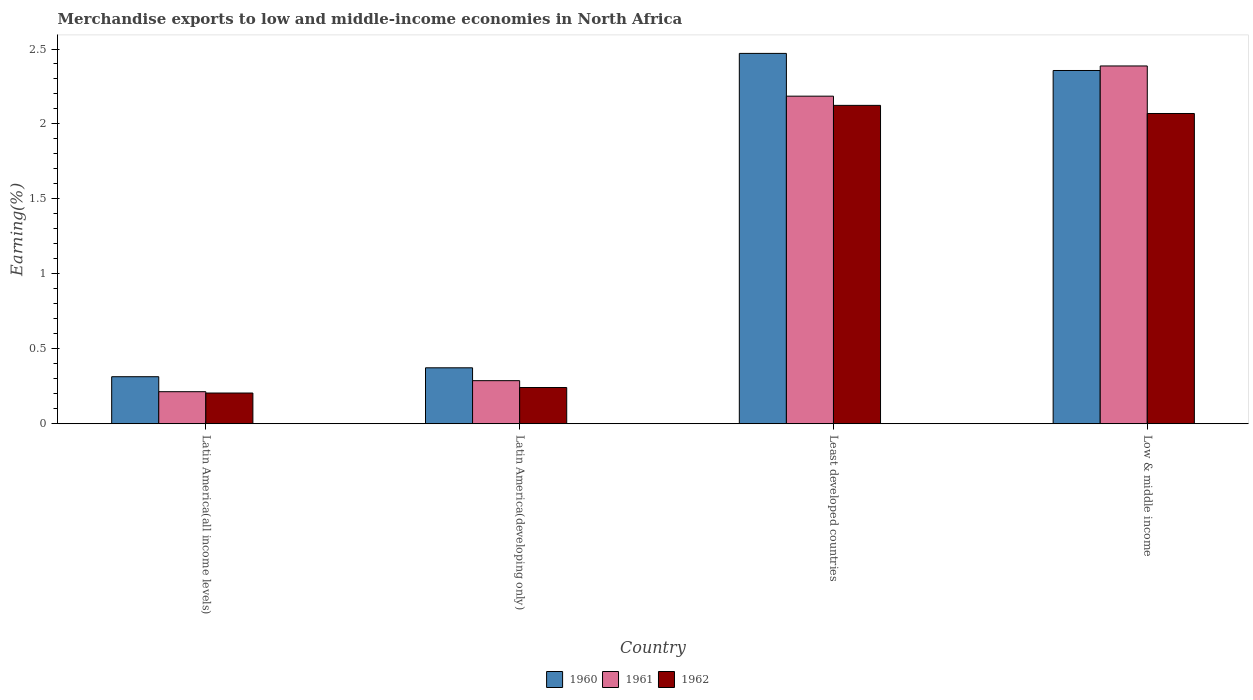How many different coloured bars are there?
Offer a very short reply. 3. How many groups of bars are there?
Offer a very short reply. 4. Are the number of bars on each tick of the X-axis equal?
Offer a very short reply. Yes. How many bars are there on the 4th tick from the left?
Give a very brief answer. 3. How many bars are there on the 2nd tick from the right?
Your response must be concise. 3. What is the label of the 1st group of bars from the left?
Your response must be concise. Latin America(all income levels). In how many cases, is the number of bars for a given country not equal to the number of legend labels?
Your answer should be compact. 0. What is the percentage of amount earned from merchandise exports in 1961 in Latin America(developing only)?
Offer a terse response. 0.29. Across all countries, what is the maximum percentage of amount earned from merchandise exports in 1961?
Provide a short and direct response. 2.39. Across all countries, what is the minimum percentage of amount earned from merchandise exports in 1961?
Give a very brief answer. 0.21. In which country was the percentage of amount earned from merchandise exports in 1961 maximum?
Offer a terse response. Low & middle income. In which country was the percentage of amount earned from merchandise exports in 1960 minimum?
Your answer should be compact. Latin America(all income levels). What is the total percentage of amount earned from merchandise exports in 1962 in the graph?
Provide a short and direct response. 4.64. What is the difference between the percentage of amount earned from merchandise exports in 1960 in Latin America(all income levels) and that in Latin America(developing only)?
Offer a very short reply. -0.06. What is the difference between the percentage of amount earned from merchandise exports in 1960 in Low & middle income and the percentage of amount earned from merchandise exports in 1962 in Least developed countries?
Make the answer very short. 0.23. What is the average percentage of amount earned from merchandise exports in 1960 per country?
Keep it short and to the point. 1.38. What is the difference between the percentage of amount earned from merchandise exports of/in 1961 and percentage of amount earned from merchandise exports of/in 1960 in Least developed countries?
Ensure brevity in your answer.  -0.29. In how many countries, is the percentage of amount earned from merchandise exports in 1962 greater than 1.5 %?
Your answer should be very brief. 2. What is the ratio of the percentage of amount earned from merchandise exports in 1962 in Latin America(all income levels) to that in Least developed countries?
Your answer should be very brief. 0.1. Is the difference between the percentage of amount earned from merchandise exports in 1961 in Latin America(all income levels) and Least developed countries greater than the difference between the percentage of amount earned from merchandise exports in 1960 in Latin America(all income levels) and Least developed countries?
Your response must be concise. Yes. What is the difference between the highest and the second highest percentage of amount earned from merchandise exports in 1961?
Your answer should be very brief. -2.1. What is the difference between the highest and the lowest percentage of amount earned from merchandise exports in 1960?
Make the answer very short. 2.16. In how many countries, is the percentage of amount earned from merchandise exports in 1962 greater than the average percentage of amount earned from merchandise exports in 1962 taken over all countries?
Offer a terse response. 2. What does the 2nd bar from the left in Latin America(developing only) represents?
Your answer should be very brief. 1961. What does the 3rd bar from the right in Latin America(developing only) represents?
Your response must be concise. 1960. Is it the case that in every country, the sum of the percentage of amount earned from merchandise exports in 1962 and percentage of amount earned from merchandise exports in 1961 is greater than the percentage of amount earned from merchandise exports in 1960?
Make the answer very short. Yes. How many countries are there in the graph?
Keep it short and to the point. 4. Are the values on the major ticks of Y-axis written in scientific E-notation?
Your answer should be compact. No. Does the graph contain any zero values?
Make the answer very short. No. Does the graph contain grids?
Your response must be concise. No. How many legend labels are there?
Ensure brevity in your answer.  3. How are the legend labels stacked?
Ensure brevity in your answer.  Horizontal. What is the title of the graph?
Your answer should be very brief. Merchandise exports to low and middle-income economies in North Africa. What is the label or title of the Y-axis?
Make the answer very short. Earning(%). What is the Earning(%) of 1960 in Latin America(all income levels)?
Provide a succinct answer. 0.31. What is the Earning(%) in 1961 in Latin America(all income levels)?
Your answer should be compact. 0.21. What is the Earning(%) in 1962 in Latin America(all income levels)?
Give a very brief answer. 0.2. What is the Earning(%) in 1960 in Latin America(developing only)?
Make the answer very short. 0.37. What is the Earning(%) in 1961 in Latin America(developing only)?
Give a very brief answer. 0.29. What is the Earning(%) of 1962 in Latin America(developing only)?
Provide a short and direct response. 0.24. What is the Earning(%) of 1960 in Least developed countries?
Ensure brevity in your answer.  2.47. What is the Earning(%) in 1961 in Least developed countries?
Keep it short and to the point. 2.19. What is the Earning(%) in 1962 in Least developed countries?
Keep it short and to the point. 2.12. What is the Earning(%) in 1960 in Low & middle income?
Offer a very short reply. 2.36. What is the Earning(%) in 1961 in Low & middle income?
Offer a terse response. 2.39. What is the Earning(%) in 1962 in Low & middle income?
Your answer should be very brief. 2.07. Across all countries, what is the maximum Earning(%) in 1960?
Your response must be concise. 2.47. Across all countries, what is the maximum Earning(%) in 1961?
Provide a succinct answer. 2.39. Across all countries, what is the maximum Earning(%) of 1962?
Keep it short and to the point. 2.12. Across all countries, what is the minimum Earning(%) of 1960?
Your answer should be very brief. 0.31. Across all countries, what is the minimum Earning(%) of 1961?
Provide a short and direct response. 0.21. Across all countries, what is the minimum Earning(%) in 1962?
Keep it short and to the point. 0.2. What is the total Earning(%) of 1960 in the graph?
Your response must be concise. 5.51. What is the total Earning(%) in 1961 in the graph?
Offer a very short reply. 5.07. What is the total Earning(%) in 1962 in the graph?
Offer a terse response. 4.64. What is the difference between the Earning(%) in 1960 in Latin America(all income levels) and that in Latin America(developing only)?
Your response must be concise. -0.06. What is the difference between the Earning(%) in 1961 in Latin America(all income levels) and that in Latin America(developing only)?
Offer a very short reply. -0.07. What is the difference between the Earning(%) of 1962 in Latin America(all income levels) and that in Latin America(developing only)?
Offer a terse response. -0.04. What is the difference between the Earning(%) in 1960 in Latin America(all income levels) and that in Least developed countries?
Keep it short and to the point. -2.16. What is the difference between the Earning(%) in 1961 in Latin America(all income levels) and that in Least developed countries?
Make the answer very short. -1.97. What is the difference between the Earning(%) in 1962 in Latin America(all income levels) and that in Least developed countries?
Ensure brevity in your answer.  -1.92. What is the difference between the Earning(%) in 1960 in Latin America(all income levels) and that in Low & middle income?
Keep it short and to the point. -2.04. What is the difference between the Earning(%) of 1961 in Latin America(all income levels) and that in Low & middle income?
Your response must be concise. -2.17. What is the difference between the Earning(%) in 1962 in Latin America(all income levels) and that in Low & middle income?
Your response must be concise. -1.86. What is the difference between the Earning(%) of 1960 in Latin America(developing only) and that in Least developed countries?
Keep it short and to the point. -2.1. What is the difference between the Earning(%) in 1961 in Latin America(developing only) and that in Least developed countries?
Provide a short and direct response. -1.9. What is the difference between the Earning(%) in 1962 in Latin America(developing only) and that in Least developed countries?
Provide a short and direct response. -1.88. What is the difference between the Earning(%) in 1960 in Latin America(developing only) and that in Low & middle income?
Ensure brevity in your answer.  -1.98. What is the difference between the Earning(%) in 1961 in Latin America(developing only) and that in Low & middle income?
Your answer should be compact. -2.1. What is the difference between the Earning(%) in 1962 in Latin America(developing only) and that in Low & middle income?
Keep it short and to the point. -1.83. What is the difference between the Earning(%) in 1960 in Least developed countries and that in Low & middle income?
Your answer should be very brief. 0.11. What is the difference between the Earning(%) in 1961 in Least developed countries and that in Low & middle income?
Offer a terse response. -0.2. What is the difference between the Earning(%) in 1962 in Least developed countries and that in Low & middle income?
Offer a terse response. 0.05. What is the difference between the Earning(%) of 1960 in Latin America(all income levels) and the Earning(%) of 1961 in Latin America(developing only)?
Provide a short and direct response. 0.03. What is the difference between the Earning(%) in 1960 in Latin America(all income levels) and the Earning(%) in 1962 in Latin America(developing only)?
Provide a succinct answer. 0.07. What is the difference between the Earning(%) of 1961 in Latin America(all income levels) and the Earning(%) of 1962 in Latin America(developing only)?
Give a very brief answer. -0.03. What is the difference between the Earning(%) in 1960 in Latin America(all income levels) and the Earning(%) in 1961 in Least developed countries?
Keep it short and to the point. -1.87. What is the difference between the Earning(%) in 1960 in Latin America(all income levels) and the Earning(%) in 1962 in Least developed countries?
Your answer should be compact. -1.81. What is the difference between the Earning(%) in 1961 in Latin America(all income levels) and the Earning(%) in 1962 in Least developed countries?
Your answer should be very brief. -1.91. What is the difference between the Earning(%) in 1960 in Latin America(all income levels) and the Earning(%) in 1961 in Low & middle income?
Offer a terse response. -2.07. What is the difference between the Earning(%) of 1960 in Latin America(all income levels) and the Earning(%) of 1962 in Low & middle income?
Provide a succinct answer. -1.76. What is the difference between the Earning(%) in 1961 in Latin America(all income levels) and the Earning(%) in 1962 in Low & middle income?
Your response must be concise. -1.86. What is the difference between the Earning(%) in 1960 in Latin America(developing only) and the Earning(%) in 1961 in Least developed countries?
Make the answer very short. -1.81. What is the difference between the Earning(%) of 1960 in Latin America(developing only) and the Earning(%) of 1962 in Least developed countries?
Offer a very short reply. -1.75. What is the difference between the Earning(%) of 1961 in Latin America(developing only) and the Earning(%) of 1962 in Least developed countries?
Provide a succinct answer. -1.84. What is the difference between the Earning(%) of 1960 in Latin America(developing only) and the Earning(%) of 1961 in Low & middle income?
Offer a terse response. -2.01. What is the difference between the Earning(%) in 1960 in Latin America(developing only) and the Earning(%) in 1962 in Low & middle income?
Keep it short and to the point. -1.7. What is the difference between the Earning(%) of 1961 in Latin America(developing only) and the Earning(%) of 1962 in Low & middle income?
Offer a terse response. -1.78. What is the difference between the Earning(%) of 1960 in Least developed countries and the Earning(%) of 1961 in Low & middle income?
Offer a very short reply. 0.08. What is the difference between the Earning(%) of 1960 in Least developed countries and the Earning(%) of 1962 in Low & middle income?
Ensure brevity in your answer.  0.4. What is the difference between the Earning(%) in 1961 in Least developed countries and the Earning(%) in 1962 in Low & middle income?
Offer a terse response. 0.12. What is the average Earning(%) of 1960 per country?
Provide a succinct answer. 1.38. What is the average Earning(%) in 1961 per country?
Your answer should be very brief. 1.27. What is the average Earning(%) of 1962 per country?
Your answer should be very brief. 1.16. What is the difference between the Earning(%) of 1960 and Earning(%) of 1961 in Latin America(all income levels)?
Give a very brief answer. 0.1. What is the difference between the Earning(%) in 1960 and Earning(%) in 1962 in Latin America(all income levels)?
Make the answer very short. 0.11. What is the difference between the Earning(%) of 1961 and Earning(%) of 1962 in Latin America(all income levels)?
Ensure brevity in your answer.  0.01. What is the difference between the Earning(%) of 1960 and Earning(%) of 1961 in Latin America(developing only)?
Ensure brevity in your answer.  0.09. What is the difference between the Earning(%) of 1960 and Earning(%) of 1962 in Latin America(developing only)?
Provide a succinct answer. 0.13. What is the difference between the Earning(%) of 1961 and Earning(%) of 1962 in Latin America(developing only)?
Offer a very short reply. 0.05. What is the difference between the Earning(%) in 1960 and Earning(%) in 1961 in Least developed countries?
Provide a short and direct response. 0.29. What is the difference between the Earning(%) of 1960 and Earning(%) of 1962 in Least developed countries?
Ensure brevity in your answer.  0.35. What is the difference between the Earning(%) of 1961 and Earning(%) of 1962 in Least developed countries?
Ensure brevity in your answer.  0.06. What is the difference between the Earning(%) of 1960 and Earning(%) of 1961 in Low & middle income?
Give a very brief answer. -0.03. What is the difference between the Earning(%) of 1960 and Earning(%) of 1962 in Low & middle income?
Make the answer very short. 0.29. What is the difference between the Earning(%) in 1961 and Earning(%) in 1962 in Low & middle income?
Give a very brief answer. 0.32. What is the ratio of the Earning(%) in 1960 in Latin America(all income levels) to that in Latin America(developing only)?
Offer a very short reply. 0.84. What is the ratio of the Earning(%) of 1961 in Latin America(all income levels) to that in Latin America(developing only)?
Your answer should be very brief. 0.74. What is the ratio of the Earning(%) in 1962 in Latin America(all income levels) to that in Latin America(developing only)?
Offer a terse response. 0.85. What is the ratio of the Earning(%) in 1960 in Latin America(all income levels) to that in Least developed countries?
Provide a short and direct response. 0.13. What is the ratio of the Earning(%) in 1961 in Latin America(all income levels) to that in Least developed countries?
Your response must be concise. 0.1. What is the ratio of the Earning(%) in 1962 in Latin America(all income levels) to that in Least developed countries?
Offer a very short reply. 0.1. What is the ratio of the Earning(%) of 1960 in Latin America(all income levels) to that in Low & middle income?
Provide a short and direct response. 0.13. What is the ratio of the Earning(%) in 1961 in Latin America(all income levels) to that in Low & middle income?
Your answer should be very brief. 0.09. What is the ratio of the Earning(%) of 1962 in Latin America(all income levels) to that in Low & middle income?
Your answer should be compact. 0.1. What is the ratio of the Earning(%) in 1960 in Latin America(developing only) to that in Least developed countries?
Make the answer very short. 0.15. What is the ratio of the Earning(%) of 1961 in Latin America(developing only) to that in Least developed countries?
Provide a succinct answer. 0.13. What is the ratio of the Earning(%) of 1962 in Latin America(developing only) to that in Least developed countries?
Keep it short and to the point. 0.11. What is the ratio of the Earning(%) of 1960 in Latin America(developing only) to that in Low & middle income?
Give a very brief answer. 0.16. What is the ratio of the Earning(%) of 1961 in Latin America(developing only) to that in Low & middle income?
Offer a terse response. 0.12. What is the ratio of the Earning(%) in 1962 in Latin America(developing only) to that in Low & middle income?
Keep it short and to the point. 0.12. What is the ratio of the Earning(%) of 1960 in Least developed countries to that in Low & middle income?
Make the answer very short. 1.05. What is the ratio of the Earning(%) of 1961 in Least developed countries to that in Low & middle income?
Ensure brevity in your answer.  0.92. What is the ratio of the Earning(%) of 1962 in Least developed countries to that in Low & middle income?
Ensure brevity in your answer.  1.03. What is the difference between the highest and the second highest Earning(%) of 1960?
Offer a very short reply. 0.11. What is the difference between the highest and the second highest Earning(%) in 1961?
Offer a very short reply. 0.2. What is the difference between the highest and the second highest Earning(%) of 1962?
Provide a short and direct response. 0.05. What is the difference between the highest and the lowest Earning(%) of 1960?
Offer a very short reply. 2.16. What is the difference between the highest and the lowest Earning(%) of 1961?
Keep it short and to the point. 2.17. What is the difference between the highest and the lowest Earning(%) in 1962?
Your answer should be compact. 1.92. 